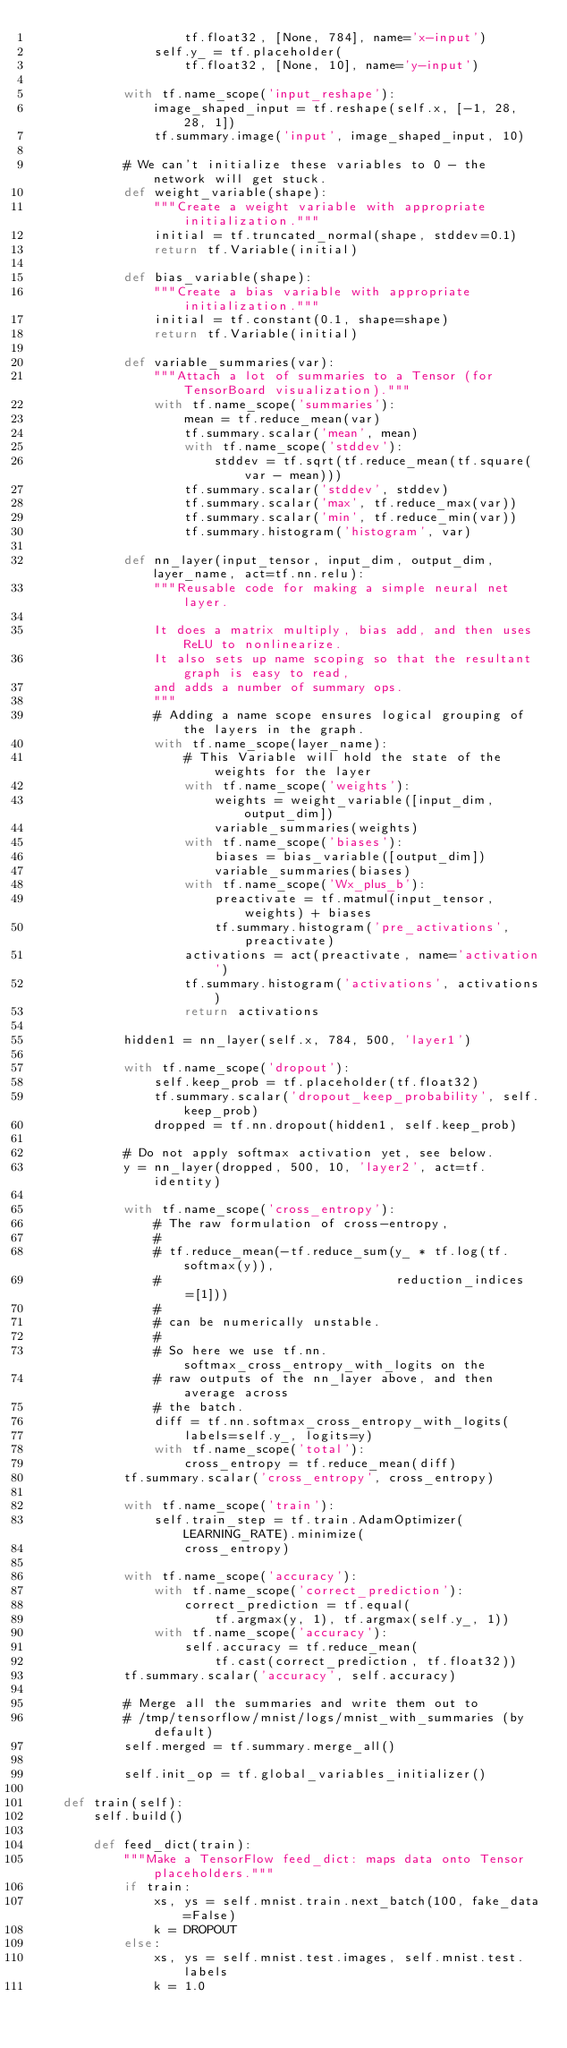<code> <loc_0><loc_0><loc_500><loc_500><_Python_>                    tf.float32, [None, 784], name='x-input')
                self.y_ = tf.placeholder(
                    tf.float32, [None, 10], name='y-input')

            with tf.name_scope('input_reshape'):
                image_shaped_input = tf.reshape(self.x, [-1, 28, 28, 1])
                tf.summary.image('input', image_shaped_input, 10)

            # We can't initialize these variables to 0 - the network will get stuck.
            def weight_variable(shape):
                """Create a weight variable with appropriate initialization."""
                initial = tf.truncated_normal(shape, stddev=0.1)
                return tf.Variable(initial)

            def bias_variable(shape):
                """Create a bias variable with appropriate initialization."""
                initial = tf.constant(0.1, shape=shape)
                return tf.Variable(initial)

            def variable_summaries(var):
                """Attach a lot of summaries to a Tensor (for TensorBoard visualization)."""
                with tf.name_scope('summaries'):
                    mean = tf.reduce_mean(var)
                    tf.summary.scalar('mean', mean)
                    with tf.name_scope('stddev'):
                        stddev = tf.sqrt(tf.reduce_mean(tf.square(var - mean)))
                    tf.summary.scalar('stddev', stddev)
                    tf.summary.scalar('max', tf.reduce_max(var))
                    tf.summary.scalar('min', tf.reduce_min(var))
                    tf.summary.histogram('histogram', var)

            def nn_layer(input_tensor, input_dim, output_dim, layer_name, act=tf.nn.relu):
                """Reusable code for making a simple neural net layer.

                It does a matrix multiply, bias add, and then uses ReLU to nonlinearize.
                It also sets up name scoping so that the resultant graph is easy to read,
                and adds a number of summary ops.
                """
                # Adding a name scope ensures logical grouping of the layers in the graph.
                with tf.name_scope(layer_name):
                    # This Variable will hold the state of the weights for the layer
                    with tf.name_scope('weights'):
                        weights = weight_variable([input_dim, output_dim])
                        variable_summaries(weights)
                    with tf.name_scope('biases'):
                        biases = bias_variable([output_dim])
                        variable_summaries(biases)
                    with tf.name_scope('Wx_plus_b'):
                        preactivate = tf.matmul(input_tensor, weights) + biases
                        tf.summary.histogram('pre_activations', preactivate)
                    activations = act(preactivate, name='activation')
                    tf.summary.histogram('activations', activations)
                    return activations

            hidden1 = nn_layer(self.x, 784, 500, 'layer1')

            with tf.name_scope('dropout'):
                self.keep_prob = tf.placeholder(tf.float32)
                tf.summary.scalar('dropout_keep_probability', self.keep_prob)
                dropped = tf.nn.dropout(hidden1, self.keep_prob)

            # Do not apply softmax activation yet, see below.
            y = nn_layer(dropped, 500, 10, 'layer2', act=tf.identity)

            with tf.name_scope('cross_entropy'):
                # The raw formulation of cross-entropy,
                #
                # tf.reduce_mean(-tf.reduce_sum(y_ * tf.log(tf.softmax(y)),
                #                               reduction_indices=[1]))
                #
                # can be numerically unstable.
                #
                # So here we use tf.nn.softmax_cross_entropy_with_logits on the
                # raw outputs of the nn_layer above, and then average across
                # the batch.
                diff = tf.nn.softmax_cross_entropy_with_logits(
                    labels=self.y_, logits=y)
                with tf.name_scope('total'):
                    cross_entropy = tf.reduce_mean(diff)
            tf.summary.scalar('cross_entropy', cross_entropy)

            with tf.name_scope('train'):
                self.train_step = tf.train.AdamOptimizer(LEARNING_RATE).minimize(
                    cross_entropy)

            with tf.name_scope('accuracy'):
                with tf.name_scope('correct_prediction'):
                    correct_prediction = tf.equal(
                        tf.argmax(y, 1), tf.argmax(self.y_, 1))
                with tf.name_scope('accuracy'):
                    self.accuracy = tf.reduce_mean(
                        tf.cast(correct_prediction, tf.float32))
            tf.summary.scalar('accuracy', self.accuracy)

            # Merge all the summaries and write them out to
            # /tmp/tensorflow/mnist/logs/mnist_with_summaries (by default)
            self.merged = tf.summary.merge_all()

            self.init_op = tf.global_variables_initializer()

    def train(self):
        self.build()

        def feed_dict(train):
            """Make a TensorFlow feed_dict: maps data onto Tensor placeholders."""
            if train:
                xs, ys = self.mnist.train.next_batch(100, fake_data=False)
                k = DROPOUT
            else:
                xs, ys = self.mnist.test.images, self.mnist.test.labels
                k = 1.0</code> 